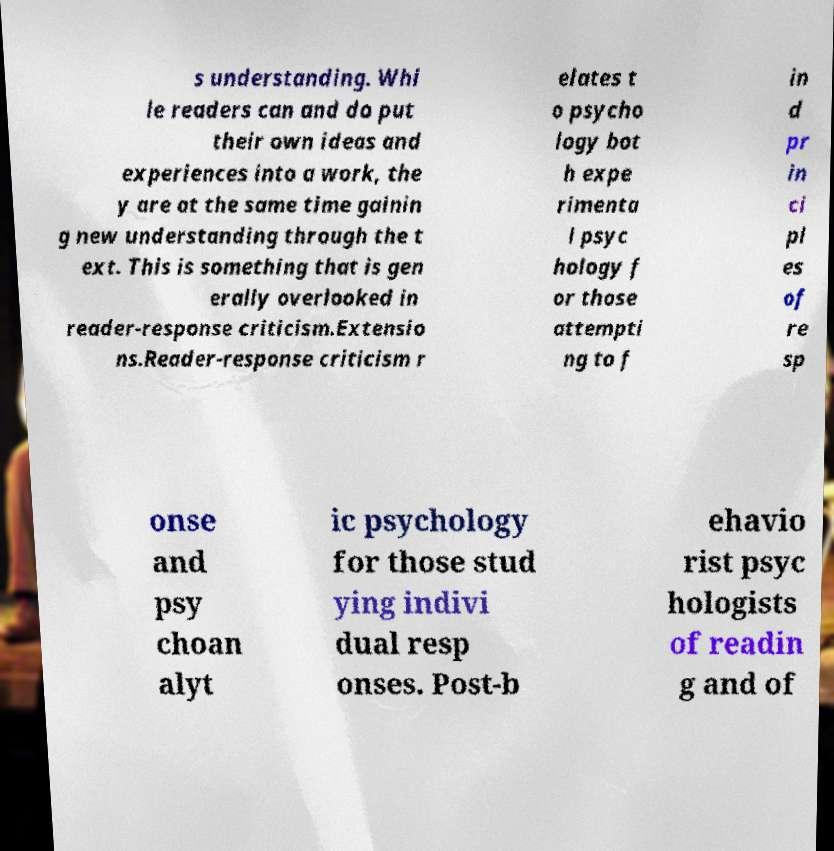There's text embedded in this image that I need extracted. Can you transcribe it verbatim? s understanding. Whi le readers can and do put their own ideas and experiences into a work, the y are at the same time gainin g new understanding through the t ext. This is something that is gen erally overlooked in reader-response criticism.Extensio ns.Reader-response criticism r elates t o psycho logy bot h expe rimenta l psyc hology f or those attempti ng to f in d pr in ci pl es of re sp onse and psy choan alyt ic psychology for those stud ying indivi dual resp onses. Post-b ehavio rist psyc hologists of readin g and of 